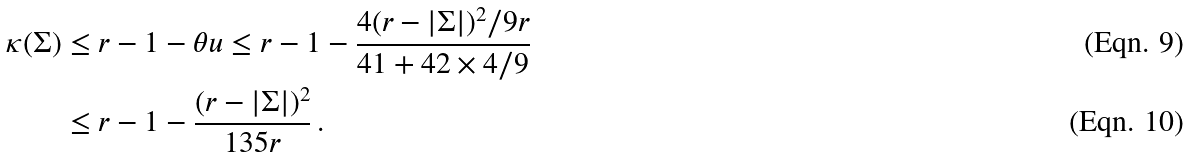Convert formula to latex. <formula><loc_0><loc_0><loc_500><loc_500>\kappa ( \Sigma ) & \leq r - 1 - \theta u \leq r - 1 - \frac { 4 ( r - | \Sigma | ) ^ { 2 } / 9 r } { 4 1 + 4 2 \times 4 / 9 } \\ & \leq r - 1 - \frac { ( r - | \Sigma | ) ^ { 2 } } { 1 3 5 r } \, .</formula> 